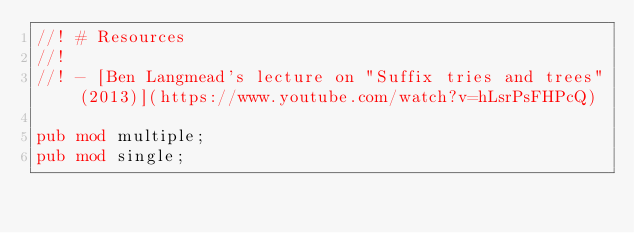Convert code to text. <code><loc_0><loc_0><loc_500><loc_500><_Rust_>//! # Resources
//!
//! - [Ben Langmead's lecture on "Suffix tries and trees" (2013)](https://www.youtube.com/watch?v=hLsrPsFHPcQ)

pub mod multiple;
pub mod single;
</code> 